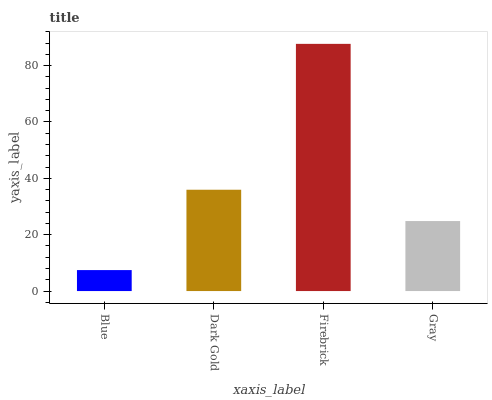Is Blue the minimum?
Answer yes or no. Yes. Is Firebrick the maximum?
Answer yes or no. Yes. Is Dark Gold the minimum?
Answer yes or no. No. Is Dark Gold the maximum?
Answer yes or no. No. Is Dark Gold greater than Blue?
Answer yes or no. Yes. Is Blue less than Dark Gold?
Answer yes or no. Yes. Is Blue greater than Dark Gold?
Answer yes or no. No. Is Dark Gold less than Blue?
Answer yes or no. No. Is Dark Gold the high median?
Answer yes or no. Yes. Is Gray the low median?
Answer yes or no. Yes. Is Gray the high median?
Answer yes or no. No. Is Firebrick the low median?
Answer yes or no. No. 